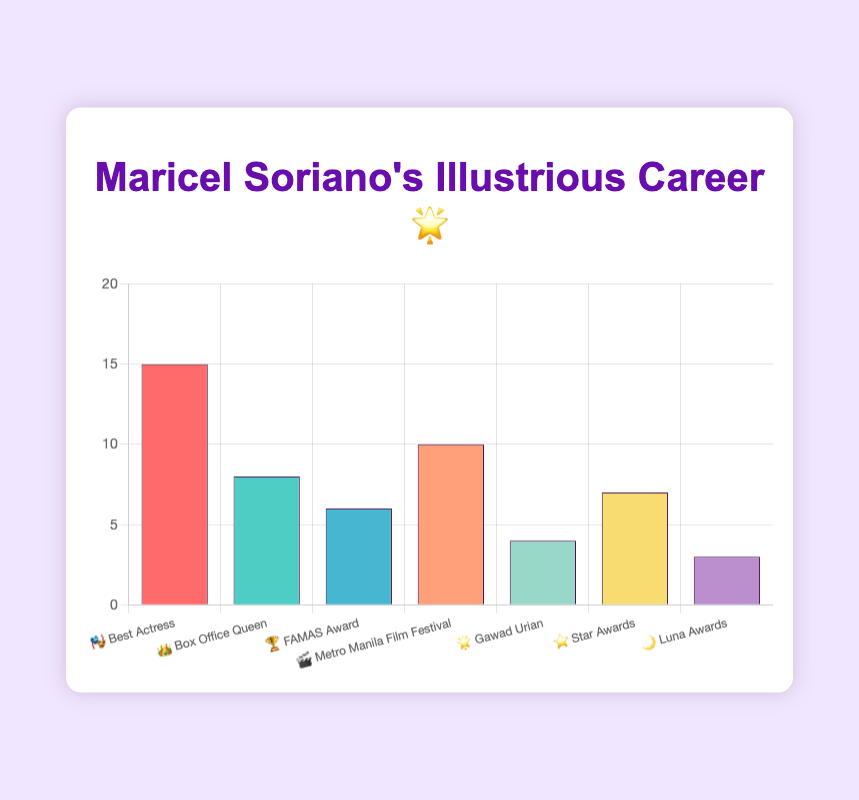what is the title of the chart? The title is displayed at the top center of the chart, which is "Maricel Soriano's Illustrious Career 🌟".
Answer: Maricel Soriano's Illustrious Career 🌟 How many categories of awards and nominations are there? The chart displays different bars, each representing an award category. By counting these bars, we see seven categories.
Answer: 7 Which award category has the highest number of awards? Look at the height of each bar and identify the tallest one, which corresponds to the "Best Actress" category with 15 awards.
Answer: Best Actress What is the total number of awards Maricel Soriano has received? Sum the counts of all categories: 15 (Best Actress) + 8 (Box Office Queen) + 6 (FAMAS Award) + 10 (Metro Manila Film Festival) + 4 (Gawad Urian) + 7 (Star Awards) + 3 (Luna Awards) = 53.
Answer: 53 What is the difference between the number of awards in the "Best Actress" and "Star Awards" categories? Subtract the count of the "Star Awards" category from the "Best Actress" category: 15 - 7 = 8.
Answer: 8 Which category has more awards, "Metro Manila Film Festival" or "Box Office Queen"? Compare the counts of the two categories: 10 (Metro Manila Film Festival) vs. 8 (Box Office Queen).
Answer: Metro Manila Film Festival What is the average number of awards per category? Calculate the sum of all awards (53) and divide by the number of categories (7). The average number of awards is 53 / 7 = 7.57.
Answer: 7.57 Are there any categories with fewer than 5 awards? If so, which ones? Check each category's count and note those with fewer than 5 awards: "Gawad Urian" with 4 awards and "Luna Awards" with 3 awards.
Answer: Gawad Urian, Luna Awards Which category has the smallest number of awards? Identify the shortest bar, which corresponds to the "Luna Awards" category with 3 awards.
Answer: Luna Awards 